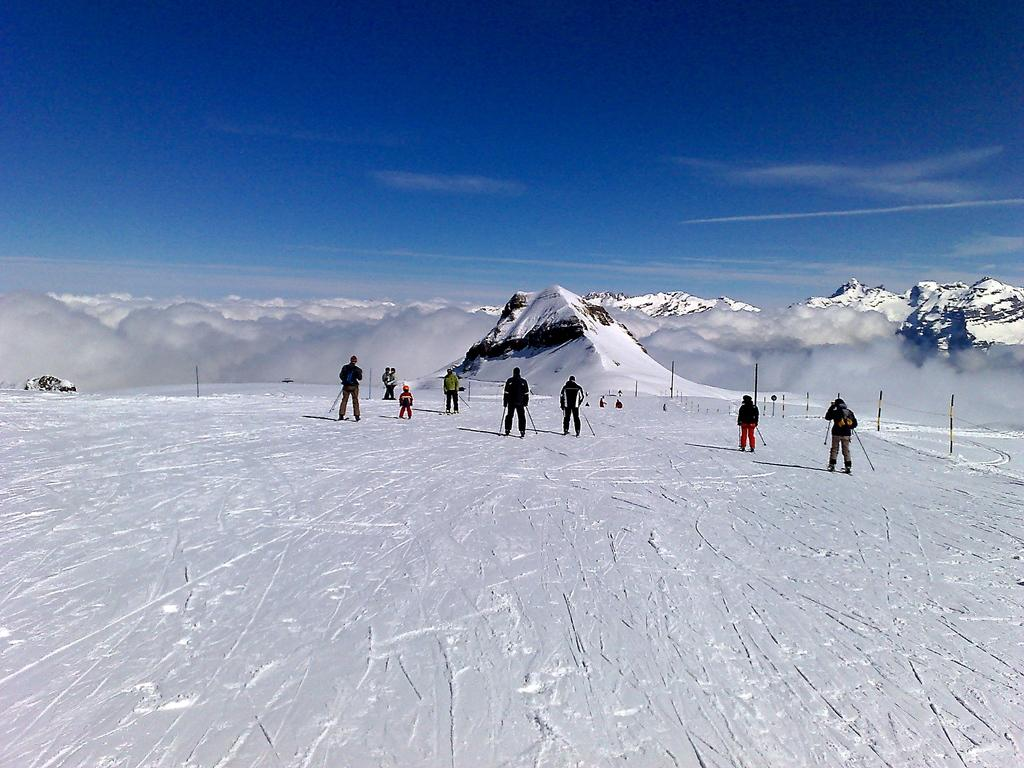What is happening in the center of the image? There are persons on the snow in the center of the image. What can be seen in the background of the image? There is a mountain, clouds, hills, and the sky visible in the background of the image. What is the ground made of in the image? There is snow at the bottom of the image. What type of notebook is being used by the persons in the image? There is no notebook present in the image; the persons are on the snow. What type of cast can be seen on the person's skin in the image? There is no cast or person's skin visible in the image; it features persons on the snow with a mountain and clouds in the background. 